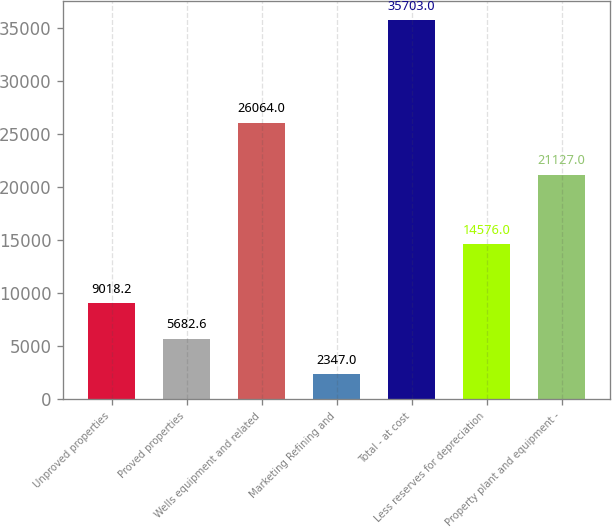Convert chart to OTSL. <chart><loc_0><loc_0><loc_500><loc_500><bar_chart><fcel>Unproved properties<fcel>Proved properties<fcel>Wells equipment and related<fcel>Marketing Refining and<fcel>Total - at cost<fcel>Less reserves for depreciation<fcel>Property plant and equipment -<nl><fcel>9018.2<fcel>5682.6<fcel>26064<fcel>2347<fcel>35703<fcel>14576<fcel>21127<nl></chart> 